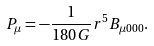Convert formula to latex. <formula><loc_0><loc_0><loc_500><loc_500>P _ { \mu } = - \frac { 1 } { 1 8 0 G } r ^ { 5 } B _ { \mu 0 0 0 } .</formula> 